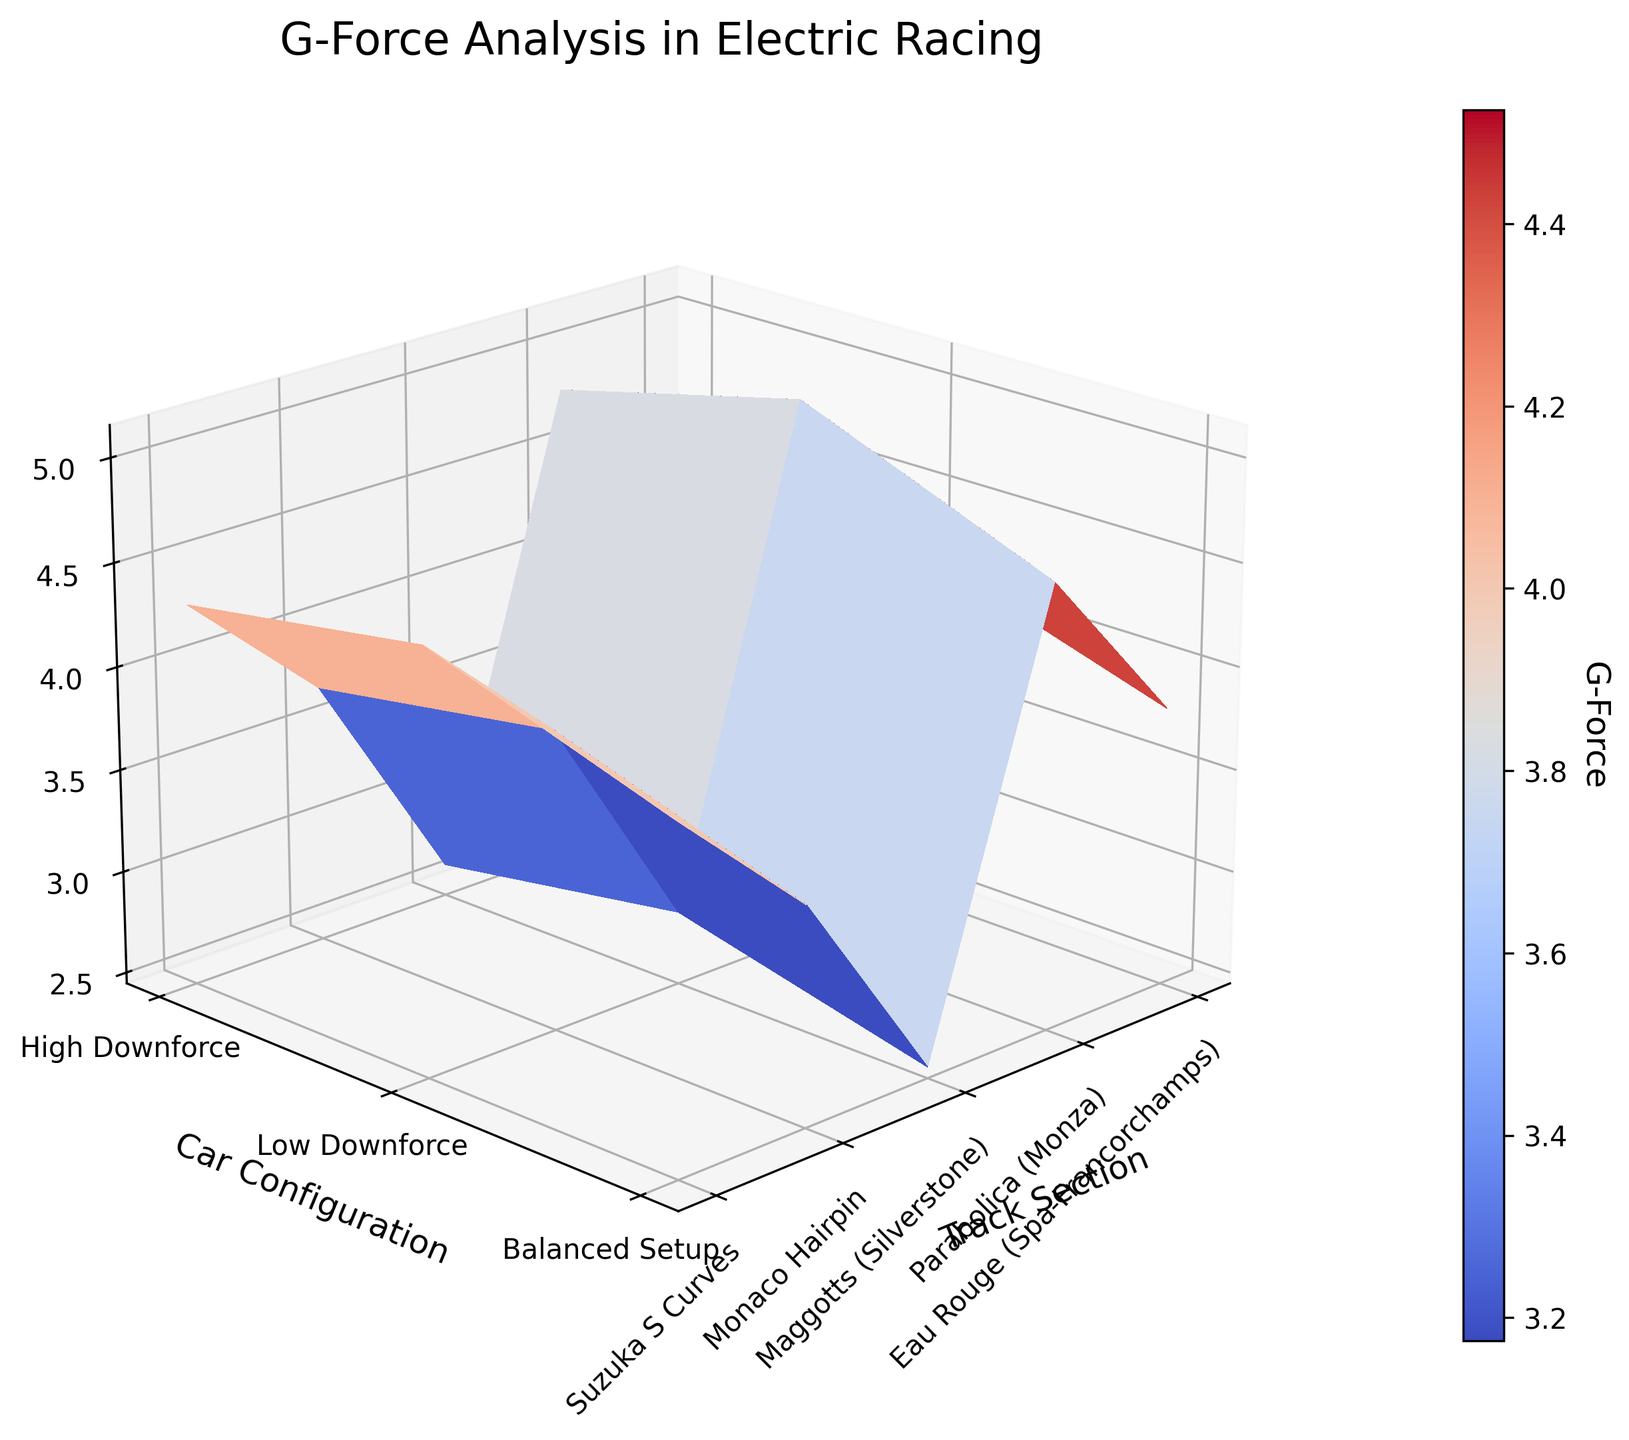Which track section has the highest G-force in a high downforce configuration? To identify the highest G-force in a high downforce configuration, look at the peaks on the surface corresponding to high downforce (one of the y-axis values). Track sections are displayed on the x-axis. The highest peak in the high downforce section corresponds to Maggotts (Silverstone).
Answer: Maggotts (Silverstone) What is the difference in G-force between the highest and lowest downforce configurations at the Monaco Hairpin? The G-forces for high and low downforce configurations at Monaco Hairpin can be read directly from the surface plot. High downforce is 2.8 and low downforce is 2.5. The difference is calculated by subtracting the values: 2.8 - 2.5.
Answer: 0.3 Which car configuration experiences the least G-force at the Suzuka S Curves? To find this, locate the Suzuka S Curves on the x-axis and compare the height of the surface for each car configuration (y-axis). The lowest G-force, represented by the lowest surface point, corresponds to the low downforce configuration.
Answer: Low Downforce What is the average G-force experienced at Parabolica across all car configurations? First, identify the G-forces at Parabolica for each configuration (high downforce: 3.9, low downforce: 3.5, balanced setup: 3.7). Then calculate the average by summing these values and dividing by the number of configurations: (3.9 + 3.5 + 3.7) / 3.
Answer: 3.7 How does the G-force at Maggotts with a balanced setup compare to the G-force at Eau Rouge with a low downforce setup? Locate the G-forces at these points on the surface plot: Maggotts with a balanced setup is 4.8 and Eau Rouge with a low downforce setup is 3.8. Comparison shows that Maggotts with a balanced setup is higher.
Answer: Maggotts with balanced setup is higher What is the median G-force across all track sections in a low downforce configuration? List all G-forces in a low downforce configuration (3.8 at Eau Rouge, 3.5 at Parabolica, 4.6 at Maggotts, 2.5 at Monaco Hairpin, 4.1 at Suzuka S Curves) and sort them (2.5, 3.5, 3.8, 4.1, 4.6). The median is the middle value, which is 3.8.
Answer: 3.8 Which track section shows the greatest variation in G-force among different car configurations? Compare the difference in G-force for each track section among different configurations. Maggotts (Silverstone) has high G-force values (5.1, 4.6, 4.8), indicating the greatest variation.
Answer: Maggotts (Silverstone) What is the total number of data points displayed on the plot? Count the number of unique track sections (5) and car configurations (3). Multiply these values: 5 x 3.
Answer: 15 What is the G-force range (difference between maximum and minimum) observed at Parabolica? Identify the G-forces at Parabolica (3.9, 3.5, 3.7). The range is found by subtracting the smallest value from the largest: 3.9 - 3.5.
Answer: 0.4 